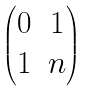<formula> <loc_0><loc_0><loc_500><loc_500>\begin{pmatrix} 0 & 1 \\ 1 & n \end{pmatrix}</formula> 